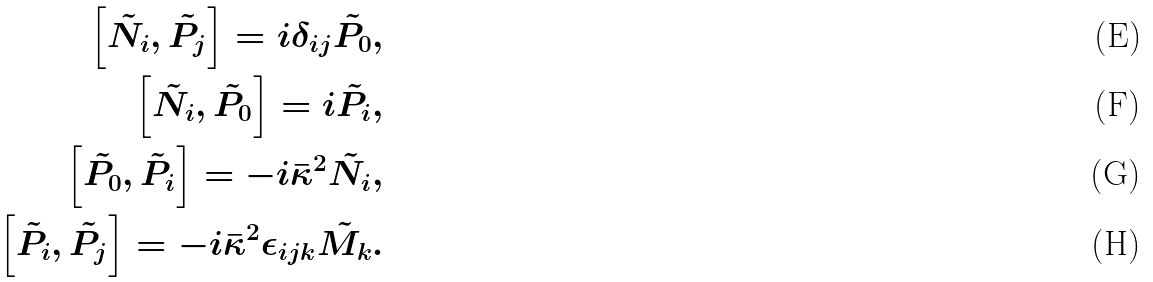<formula> <loc_0><loc_0><loc_500><loc_500>\left [ \tilde { N _ { i } } , \tilde { P _ { j } } \right ] = i \delta _ { i j } \tilde { P _ { 0 } } , \\ \left [ \tilde { N _ { i } } , \tilde { P _ { 0 } } \right ] = i \tilde { P _ { i } } , \\ \left [ \tilde { P _ { 0 } } , \tilde { P _ { i } } \right ] = - i \bar { \kappa } ^ { 2 } \tilde { N _ { i } } , \\ \left [ \tilde { P _ { i } } , \tilde { P _ { j } } \right ] = - i \bar { \kappa } ^ { 2 } \epsilon _ { i j k } \tilde { M _ { k } } .</formula> 